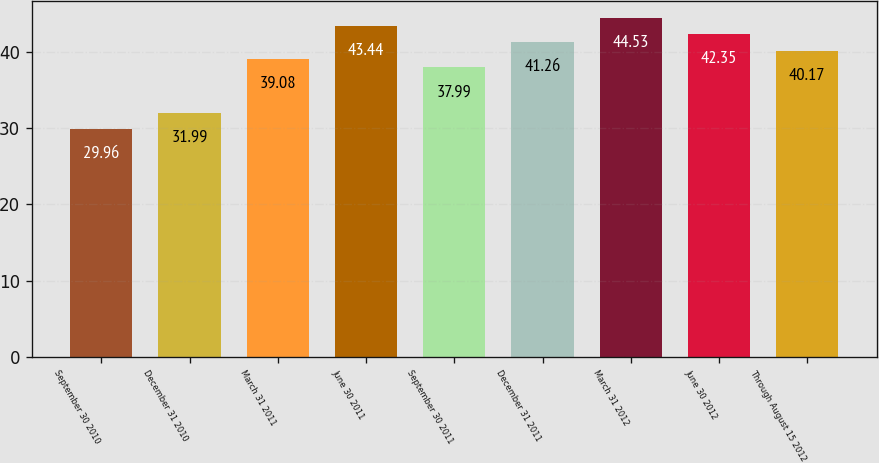Convert chart. <chart><loc_0><loc_0><loc_500><loc_500><bar_chart><fcel>September 30 2010<fcel>December 31 2010<fcel>March 31 2011<fcel>June 30 2011<fcel>September 30 2011<fcel>December 31 2011<fcel>March 31 2012<fcel>June 30 2012<fcel>Through August 15 2012<nl><fcel>29.96<fcel>31.99<fcel>39.08<fcel>43.44<fcel>37.99<fcel>41.26<fcel>44.53<fcel>42.35<fcel>40.17<nl></chart> 